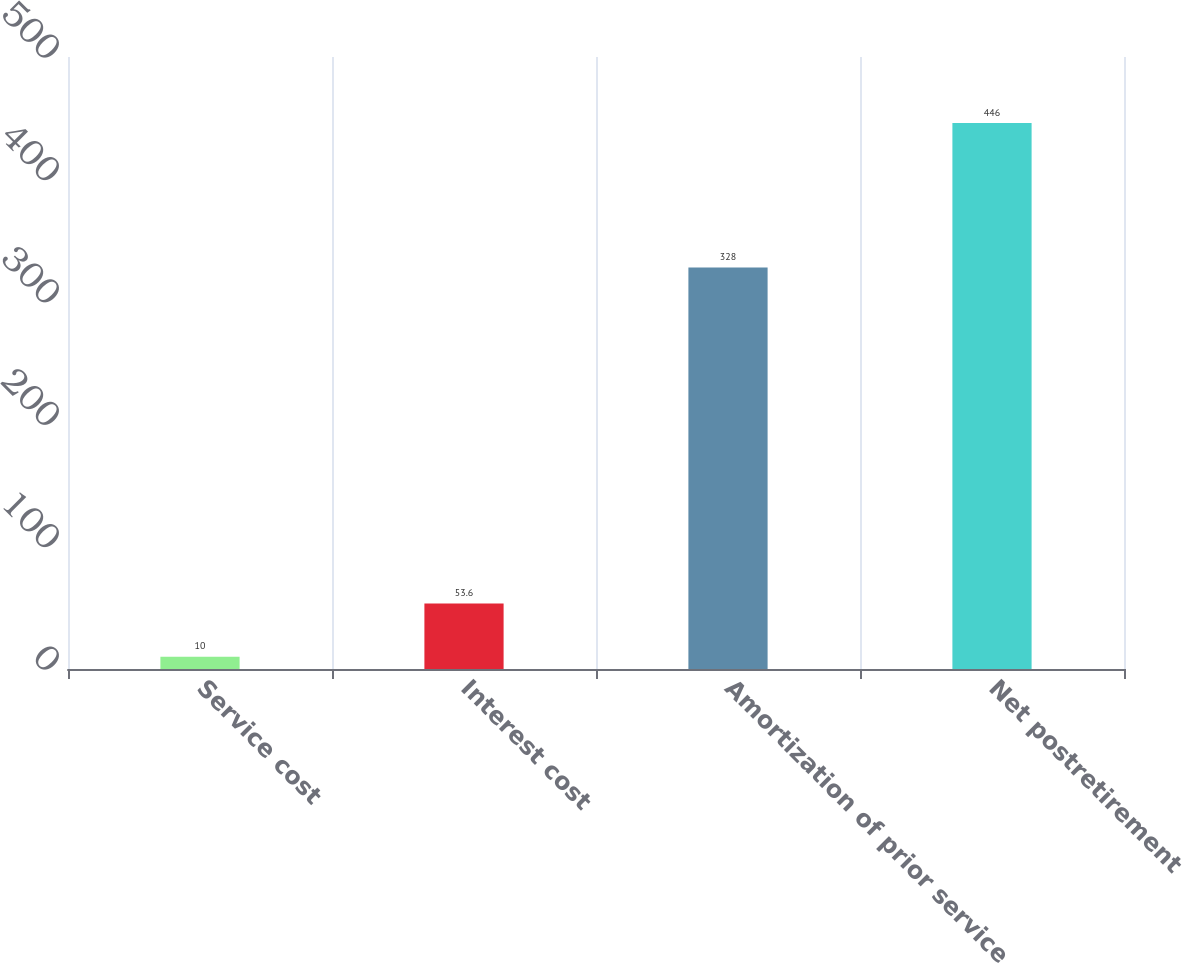Convert chart. <chart><loc_0><loc_0><loc_500><loc_500><bar_chart><fcel>Service cost<fcel>Interest cost<fcel>Amortization of prior service<fcel>Net postretirement<nl><fcel>10<fcel>53.6<fcel>328<fcel>446<nl></chart> 